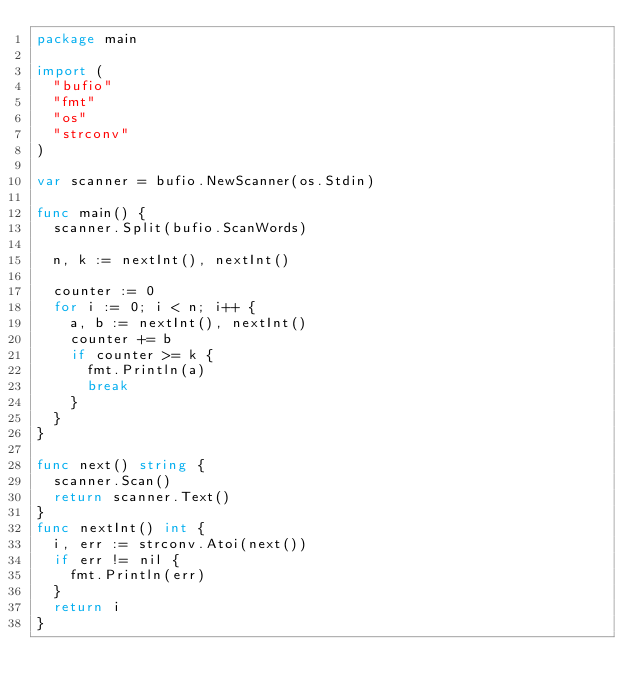<code> <loc_0><loc_0><loc_500><loc_500><_Go_>package main

import (
	"bufio"
	"fmt"
	"os"
	"strconv"
)

var scanner = bufio.NewScanner(os.Stdin)

func main() {
	scanner.Split(bufio.ScanWords)

	n, k := nextInt(), nextInt()

	counter := 0
	for i := 0; i < n; i++ {
		a, b := nextInt(), nextInt()
		counter += b
		if counter >= k {
			fmt.Println(a)
			break
		}
	}
}

func next() string {
	scanner.Scan()
	return scanner.Text()
}
func nextInt() int {
	i, err := strconv.Atoi(next())
	if err != nil {
		fmt.Println(err)
	}
	return i
}
</code> 